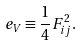<formula> <loc_0><loc_0><loc_500><loc_500>\ e _ { V } \equiv \frac { 1 } { 4 } F _ { i j } ^ { 2 } .</formula> 